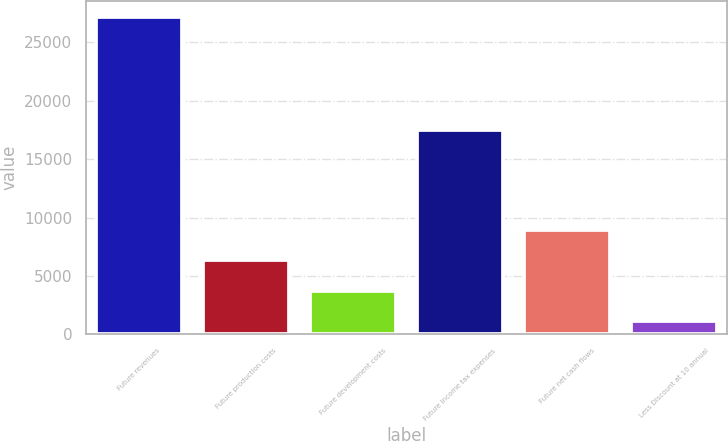Convert chart. <chart><loc_0><loc_0><loc_500><loc_500><bar_chart><fcel>Future revenues<fcel>Future production costs<fcel>Future development costs<fcel>Future income tax expenses<fcel>Future net cash flows<fcel>Less Discount at 10 annual<nl><fcel>27162<fcel>6319.6<fcel>3714.3<fcel>17510<fcel>8924.9<fcel>1109<nl></chart> 